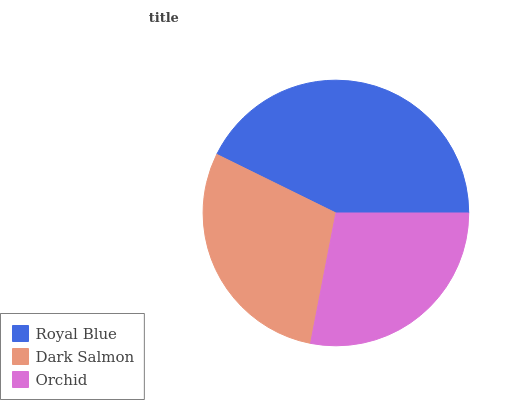Is Orchid the minimum?
Answer yes or no. Yes. Is Royal Blue the maximum?
Answer yes or no. Yes. Is Dark Salmon the minimum?
Answer yes or no. No. Is Dark Salmon the maximum?
Answer yes or no. No. Is Royal Blue greater than Dark Salmon?
Answer yes or no. Yes. Is Dark Salmon less than Royal Blue?
Answer yes or no. Yes. Is Dark Salmon greater than Royal Blue?
Answer yes or no. No. Is Royal Blue less than Dark Salmon?
Answer yes or no. No. Is Dark Salmon the high median?
Answer yes or no. Yes. Is Dark Salmon the low median?
Answer yes or no. Yes. Is Orchid the high median?
Answer yes or no. No. Is Orchid the low median?
Answer yes or no. No. 